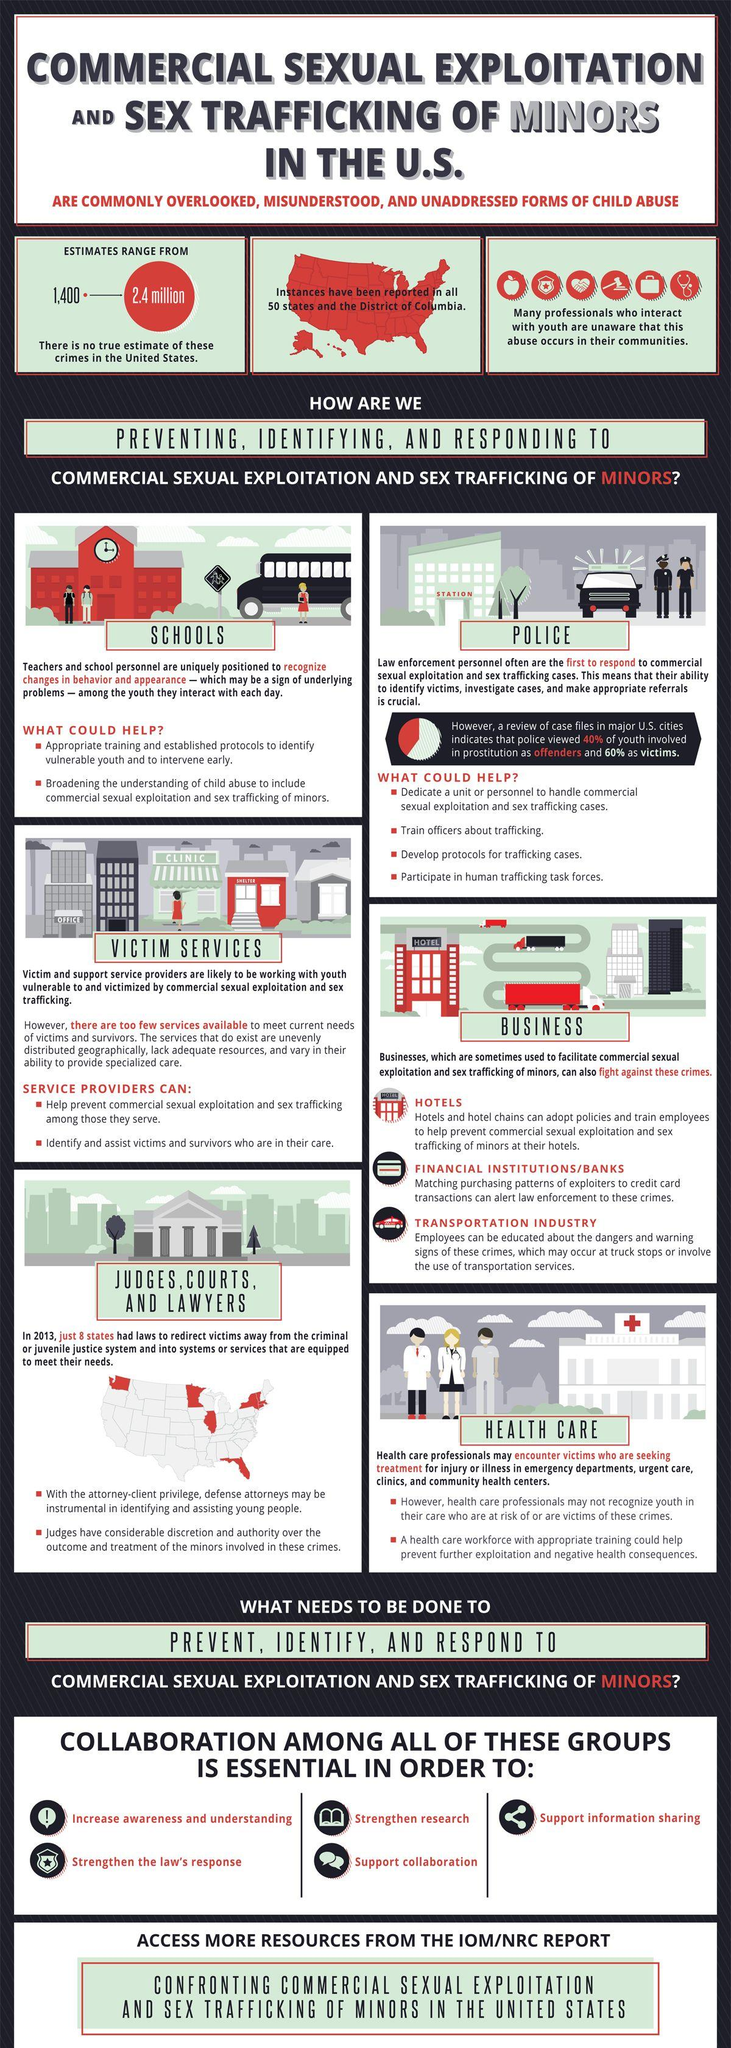Specify some key components in this picture. An estimated 2.4 million people are trafficked in the United States. 